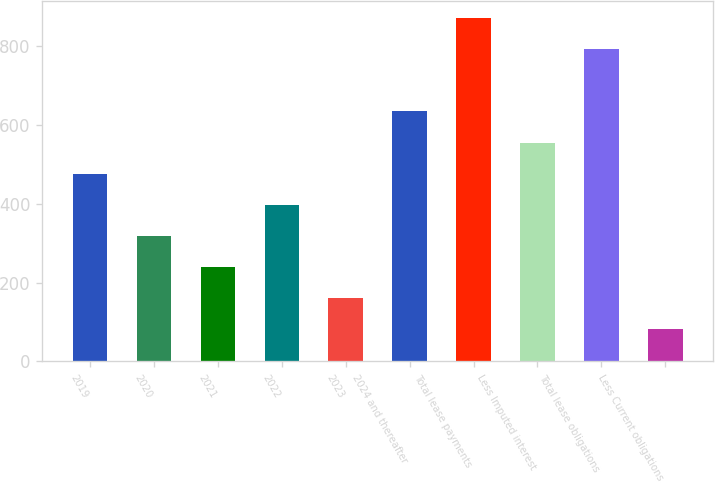<chart> <loc_0><loc_0><loc_500><loc_500><bar_chart><fcel>2019<fcel>2020<fcel>2021<fcel>2022<fcel>2023<fcel>2024 and thereafter<fcel>Total lease payments<fcel>Less Imputed interest<fcel>Total lease obligations<fcel>Less Current obligations<nl><fcel>476<fcel>318<fcel>239<fcel>397<fcel>160<fcel>634<fcel>871<fcel>555<fcel>792<fcel>81<nl></chart> 